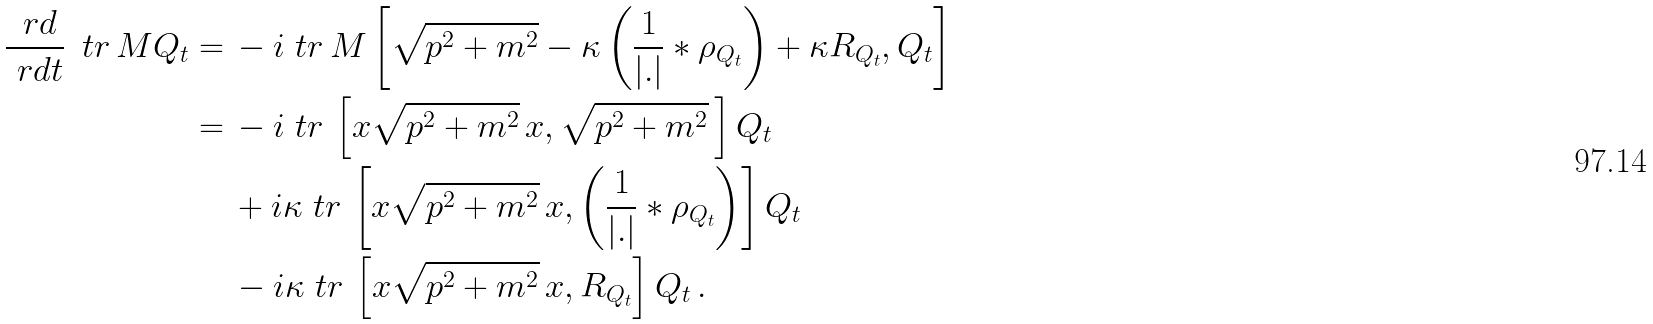<formula> <loc_0><loc_0><loc_500><loc_500>\frac { \ r d } { \ r d t } \, \ t r \, M Q _ { t } = \, & - i \ t r \, M \left [ \sqrt { p ^ { 2 } + m ^ { 2 } } - \kappa \left ( \frac { 1 } { | . | } * \rho _ { Q _ { t } } \right ) + \kappa R _ { Q _ { t } } , Q _ { t } \right ] \\ = \, & - i \ t r \, \left [ x \sqrt { p ^ { 2 } + m ^ { 2 } } \, x , \sqrt { p ^ { 2 } + m ^ { 2 } } \, \right ] Q _ { t } \\ & + i \kappa \ t r \, \left [ x \sqrt { p ^ { 2 } + m ^ { 2 } } \, x , \left ( \frac { 1 } { | . | } * \rho _ { Q _ { t } } \right ) \right ] Q _ { t } \\ & - i \kappa \ t r \, \left [ x \sqrt { p ^ { 2 } + m ^ { 2 } } \, x , R _ { Q _ { t } } \right ] Q _ { t } \, .</formula> 